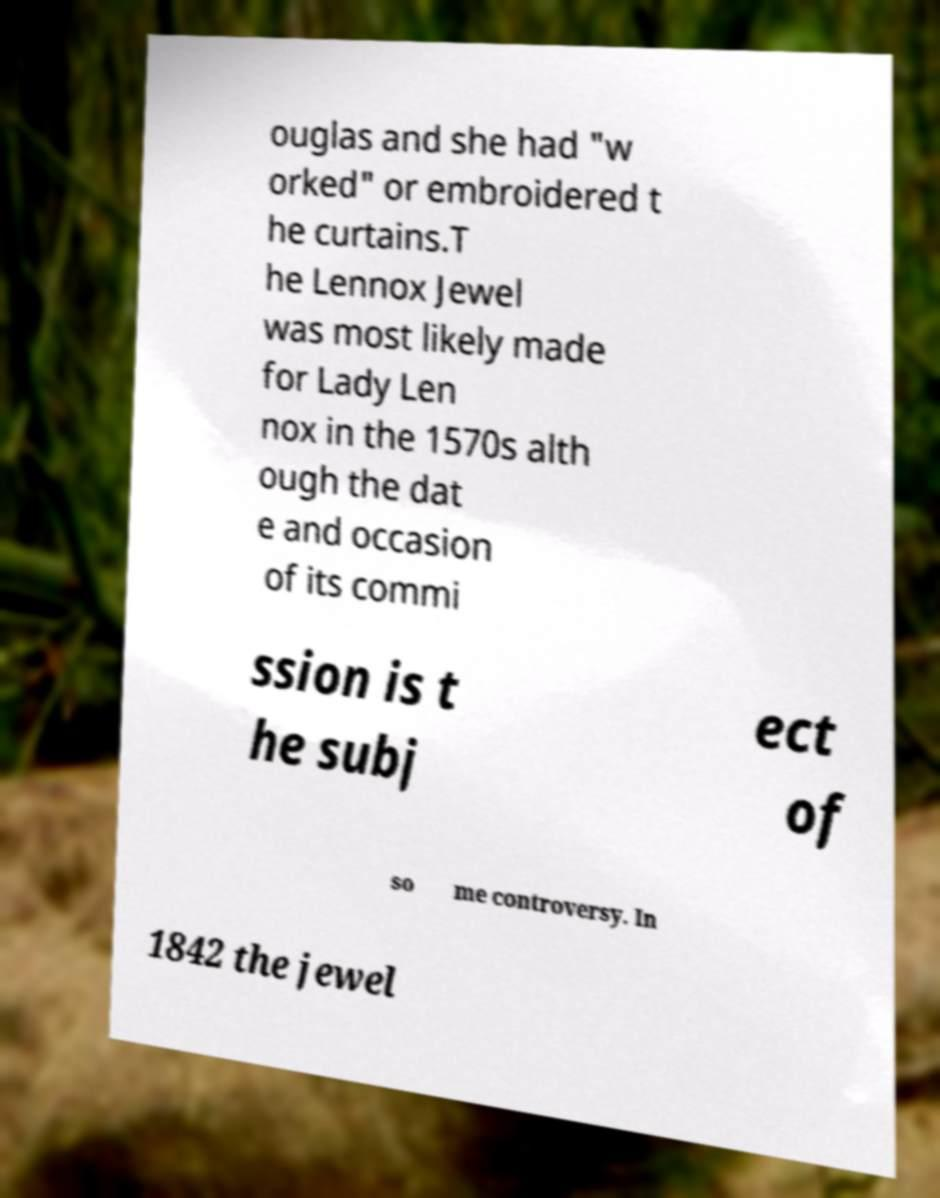Could you assist in decoding the text presented in this image and type it out clearly? ouglas and she had "w orked" or embroidered t he curtains.T he Lennox Jewel was most likely made for Lady Len nox in the 1570s alth ough the dat e and occasion of its commi ssion is t he subj ect of so me controversy. In 1842 the jewel 